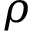<formula> <loc_0><loc_0><loc_500><loc_500>\rho</formula> 